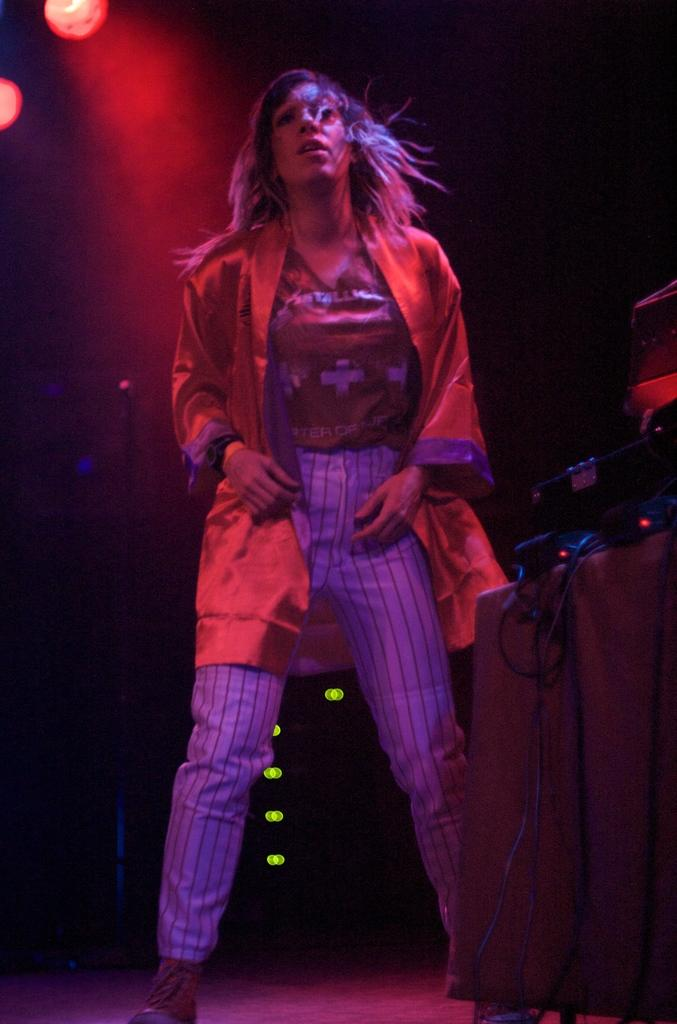What is the person in the image wearing? There is a person with a dress in the image. What type of object can be seen in the image besides the person? There is an electronic device, a wire, and a light in the image. What is the color of the background in the image? The background of the image is black. What type of wood can be seen in the shape of a pin in the image? There is no wood, shape, or pin present in the image. 